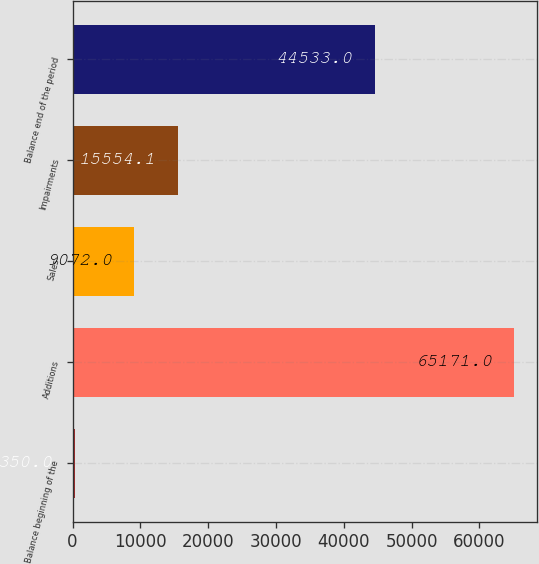<chart> <loc_0><loc_0><loc_500><loc_500><bar_chart><fcel>Balance beginning of the<fcel>Additions<fcel>Sales<fcel>Impairments<fcel>Balance end of the period<nl><fcel>350<fcel>65171<fcel>9072<fcel>15554.1<fcel>44533<nl></chart> 